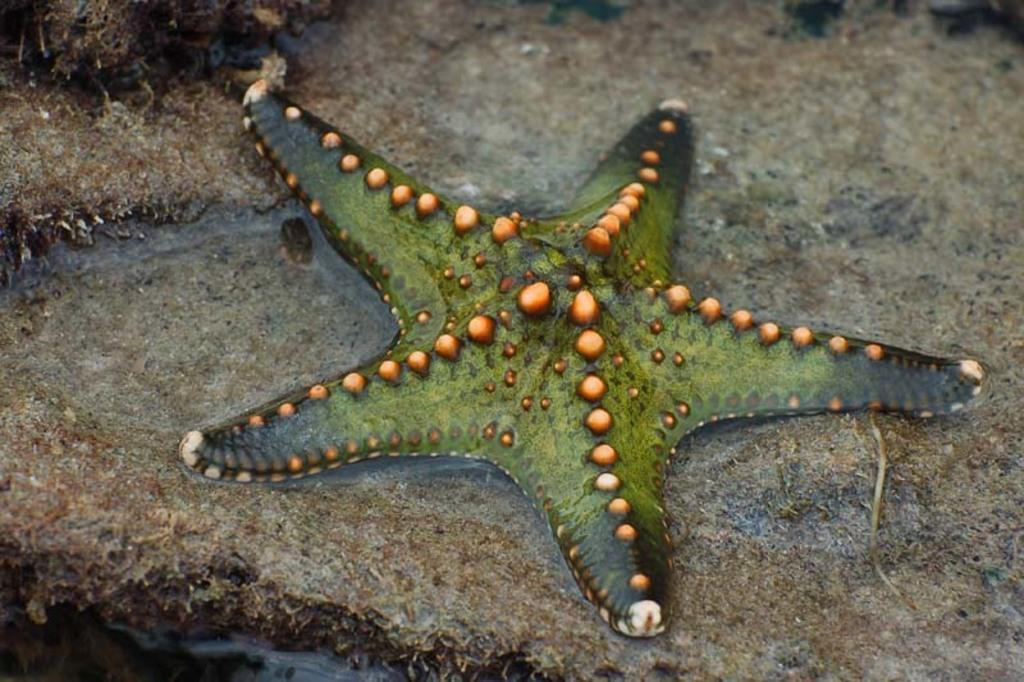What type of marine animal is in the image? There is a starfish in the image. What is the starfish situated on in the image? The starfish is situated on a rock in the image. What is the primary element surrounding the starfish? Water is visible on the rock in the image. What does the fireman's mom say about the starfish in the image? There is no fireman or his mom present in the image, so it is not possible to answer that question. 